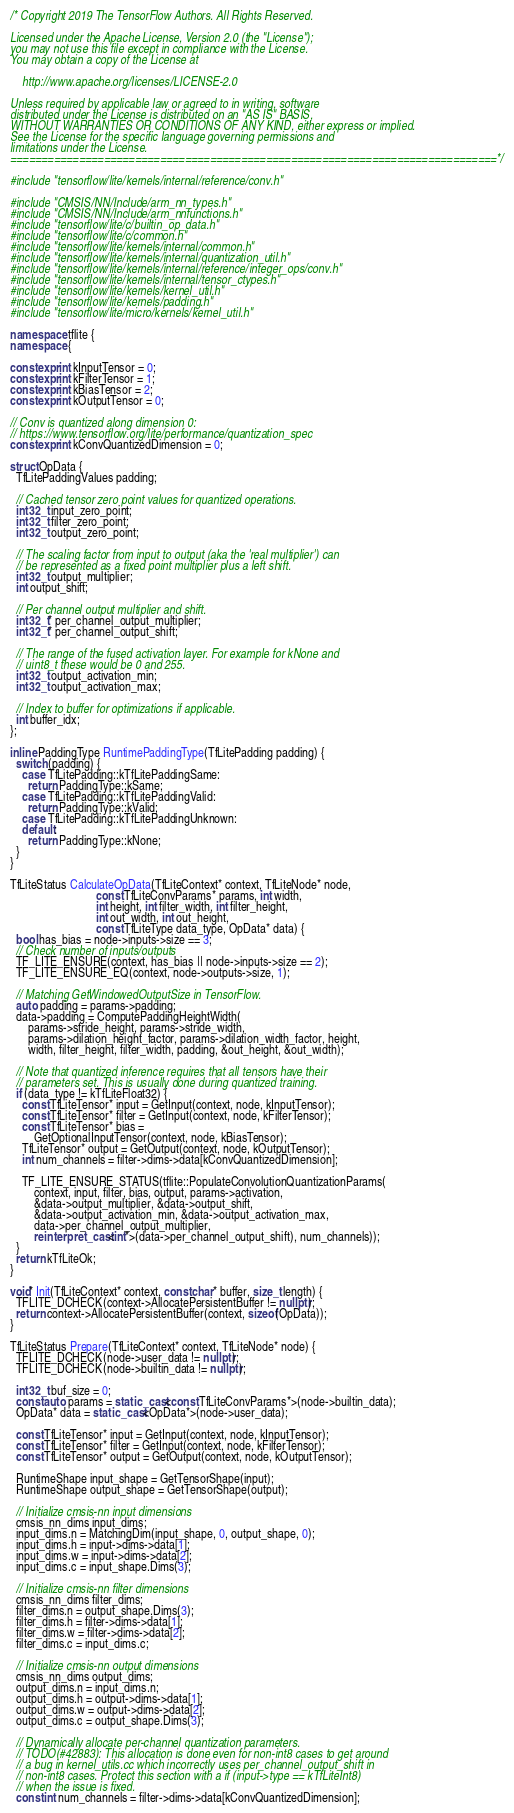Convert code to text. <code><loc_0><loc_0><loc_500><loc_500><_C++_>/* Copyright 2019 The TensorFlow Authors. All Rights Reserved.

Licensed under the Apache License, Version 2.0 (the "License");
you may not use this file except in compliance with the License.
You may obtain a copy of the License at

    http://www.apache.org/licenses/LICENSE-2.0

Unless required by applicable law or agreed to in writing, software
distributed under the License is distributed on an "AS IS" BASIS,
WITHOUT WARRANTIES OR CONDITIONS OF ANY KIND, either express or implied.
See the License for the specific language governing permissions and
limitations under the License.
==============================================================================*/

#include "tensorflow/lite/kernels/internal/reference/conv.h"

#include "CMSIS/NN/Include/arm_nn_types.h"
#include "CMSIS/NN/Include/arm_nnfunctions.h"
#include "tensorflow/lite/c/builtin_op_data.h"
#include "tensorflow/lite/c/common.h"
#include "tensorflow/lite/kernels/internal/common.h"
#include "tensorflow/lite/kernels/internal/quantization_util.h"
#include "tensorflow/lite/kernels/internal/reference/integer_ops/conv.h"
#include "tensorflow/lite/kernels/internal/tensor_ctypes.h"
#include "tensorflow/lite/kernels/kernel_util.h"
#include "tensorflow/lite/kernels/padding.h"
#include "tensorflow/lite/micro/kernels/kernel_util.h"

namespace tflite {
namespace {

constexpr int kInputTensor = 0;
constexpr int kFilterTensor = 1;
constexpr int kBiasTensor = 2;
constexpr int kOutputTensor = 0;

// Conv is quantized along dimension 0:
// https://www.tensorflow.org/lite/performance/quantization_spec
constexpr int kConvQuantizedDimension = 0;

struct OpData {
  TfLitePaddingValues padding;

  // Cached tensor zero point values for quantized operations.
  int32_t input_zero_point;
  int32_t filter_zero_point;
  int32_t output_zero_point;

  // The scaling factor from input to output (aka the 'real multiplier') can
  // be represented as a fixed point multiplier plus a left shift.
  int32_t output_multiplier;
  int output_shift;

  // Per channel output multiplier and shift.
  int32_t* per_channel_output_multiplier;
  int32_t* per_channel_output_shift;

  // The range of the fused activation layer. For example for kNone and
  // uint8_t these would be 0 and 255.
  int32_t output_activation_min;
  int32_t output_activation_max;

  // Index to buffer for optimizations if applicable.
  int buffer_idx;
};

inline PaddingType RuntimePaddingType(TfLitePadding padding) {
  switch (padding) {
    case TfLitePadding::kTfLitePaddingSame:
      return PaddingType::kSame;
    case TfLitePadding::kTfLitePaddingValid:
      return PaddingType::kValid;
    case TfLitePadding::kTfLitePaddingUnknown:
    default:
      return PaddingType::kNone;
  }
}

TfLiteStatus CalculateOpData(TfLiteContext* context, TfLiteNode* node,
                             const TfLiteConvParams* params, int width,
                             int height, int filter_width, int filter_height,
                             int out_width, int out_height,
                             const TfLiteType data_type, OpData* data) {
  bool has_bias = node->inputs->size == 3;
  // Check number of inputs/outputs
  TF_LITE_ENSURE(context, has_bias || node->inputs->size == 2);
  TF_LITE_ENSURE_EQ(context, node->outputs->size, 1);

  // Matching GetWindowedOutputSize in TensorFlow.
  auto padding = params->padding;
  data->padding = ComputePaddingHeightWidth(
      params->stride_height, params->stride_width,
      params->dilation_height_factor, params->dilation_width_factor, height,
      width, filter_height, filter_width, padding, &out_height, &out_width);

  // Note that quantized inference requires that all tensors have their
  // parameters set. This is usually done during quantized training.
  if (data_type != kTfLiteFloat32) {
    const TfLiteTensor* input = GetInput(context, node, kInputTensor);
    const TfLiteTensor* filter = GetInput(context, node, kFilterTensor);
    const TfLiteTensor* bias =
        GetOptionalInputTensor(context, node, kBiasTensor);
    TfLiteTensor* output = GetOutput(context, node, kOutputTensor);
    int num_channels = filter->dims->data[kConvQuantizedDimension];

    TF_LITE_ENSURE_STATUS(tflite::PopulateConvolutionQuantizationParams(
        context, input, filter, bias, output, params->activation,
        &data->output_multiplier, &data->output_shift,
        &data->output_activation_min, &data->output_activation_max,
        data->per_channel_output_multiplier,
        reinterpret_cast<int*>(data->per_channel_output_shift), num_channels));
  }
  return kTfLiteOk;
}

void* Init(TfLiteContext* context, const char* buffer, size_t length) {
  TFLITE_DCHECK(context->AllocatePersistentBuffer != nullptr);
  return context->AllocatePersistentBuffer(context, sizeof(OpData));
}

TfLiteStatus Prepare(TfLiteContext* context, TfLiteNode* node) {
  TFLITE_DCHECK(node->user_data != nullptr);
  TFLITE_DCHECK(node->builtin_data != nullptr);

  int32_t buf_size = 0;
  const auto params = static_cast<const TfLiteConvParams*>(node->builtin_data);
  OpData* data = static_cast<OpData*>(node->user_data);

  const TfLiteTensor* input = GetInput(context, node, kInputTensor);
  const TfLiteTensor* filter = GetInput(context, node, kFilterTensor);
  const TfLiteTensor* output = GetOutput(context, node, kOutputTensor);

  RuntimeShape input_shape = GetTensorShape(input);
  RuntimeShape output_shape = GetTensorShape(output);

  // Initialize cmsis-nn input dimensions
  cmsis_nn_dims input_dims;
  input_dims.n = MatchingDim(input_shape, 0, output_shape, 0);
  input_dims.h = input->dims->data[1];
  input_dims.w = input->dims->data[2];
  input_dims.c = input_shape.Dims(3);

  // Initialize cmsis-nn filter dimensions
  cmsis_nn_dims filter_dims;
  filter_dims.n = output_shape.Dims(3);
  filter_dims.h = filter->dims->data[1];
  filter_dims.w = filter->dims->data[2];
  filter_dims.c = input_dims.c;

  // Initialize cmsis-nn output dimensions
  cmsis_nn_dims output_dims;
  output_dims.n = input_dims.n;
  output_dims.h = output->dims->data[1];
  output_dims.w = output->dims->data[2];
  output_dims.c = output_shape.Dims(3);

  // Dynamically allocate per-channel quantization parameters.
  // TODO(#42883): This allocation is done even for non-int8 cases to get around
  // a bug in kernel_utils.cc which incorrectly uses per_channel_output_shift in
  // non-int8 cases. Protect this section with a if (input->type == kTfLiteInt8)
  // when the issue is fixed.
  const int num_channels = filter->dims->data[kConvQuantizedDimension];</code> 